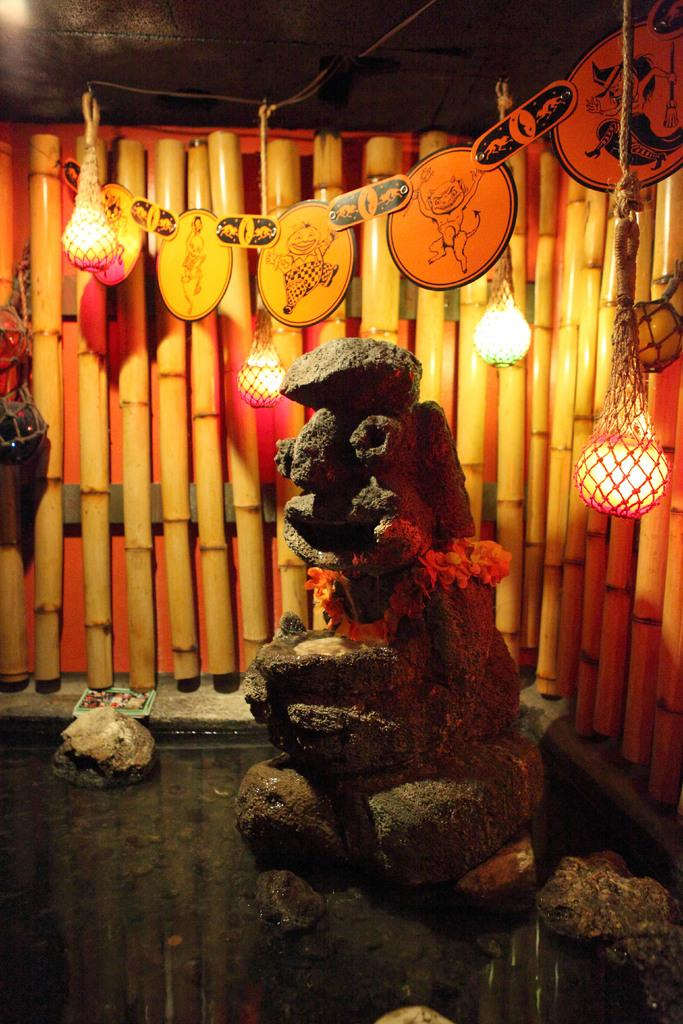What material is the sculpture made of in the image? The sculpture is made of stone in the image. Where is the sculpture located in the image? The sculpture is on the water in the image. What other objects can be seen in the image besides the sculpture? There are stones, bamboo sticks, lights, a rope, and decorative elements present in the image. What color is the army uniform in the image? There is no army or uniform present in the image; it features a stone sculpture on the water with various other objects and elements. What type of needle is used for sewing in the image? There is no needle present in the image; it features a stone sculpture on the water with various other objects and elements. 